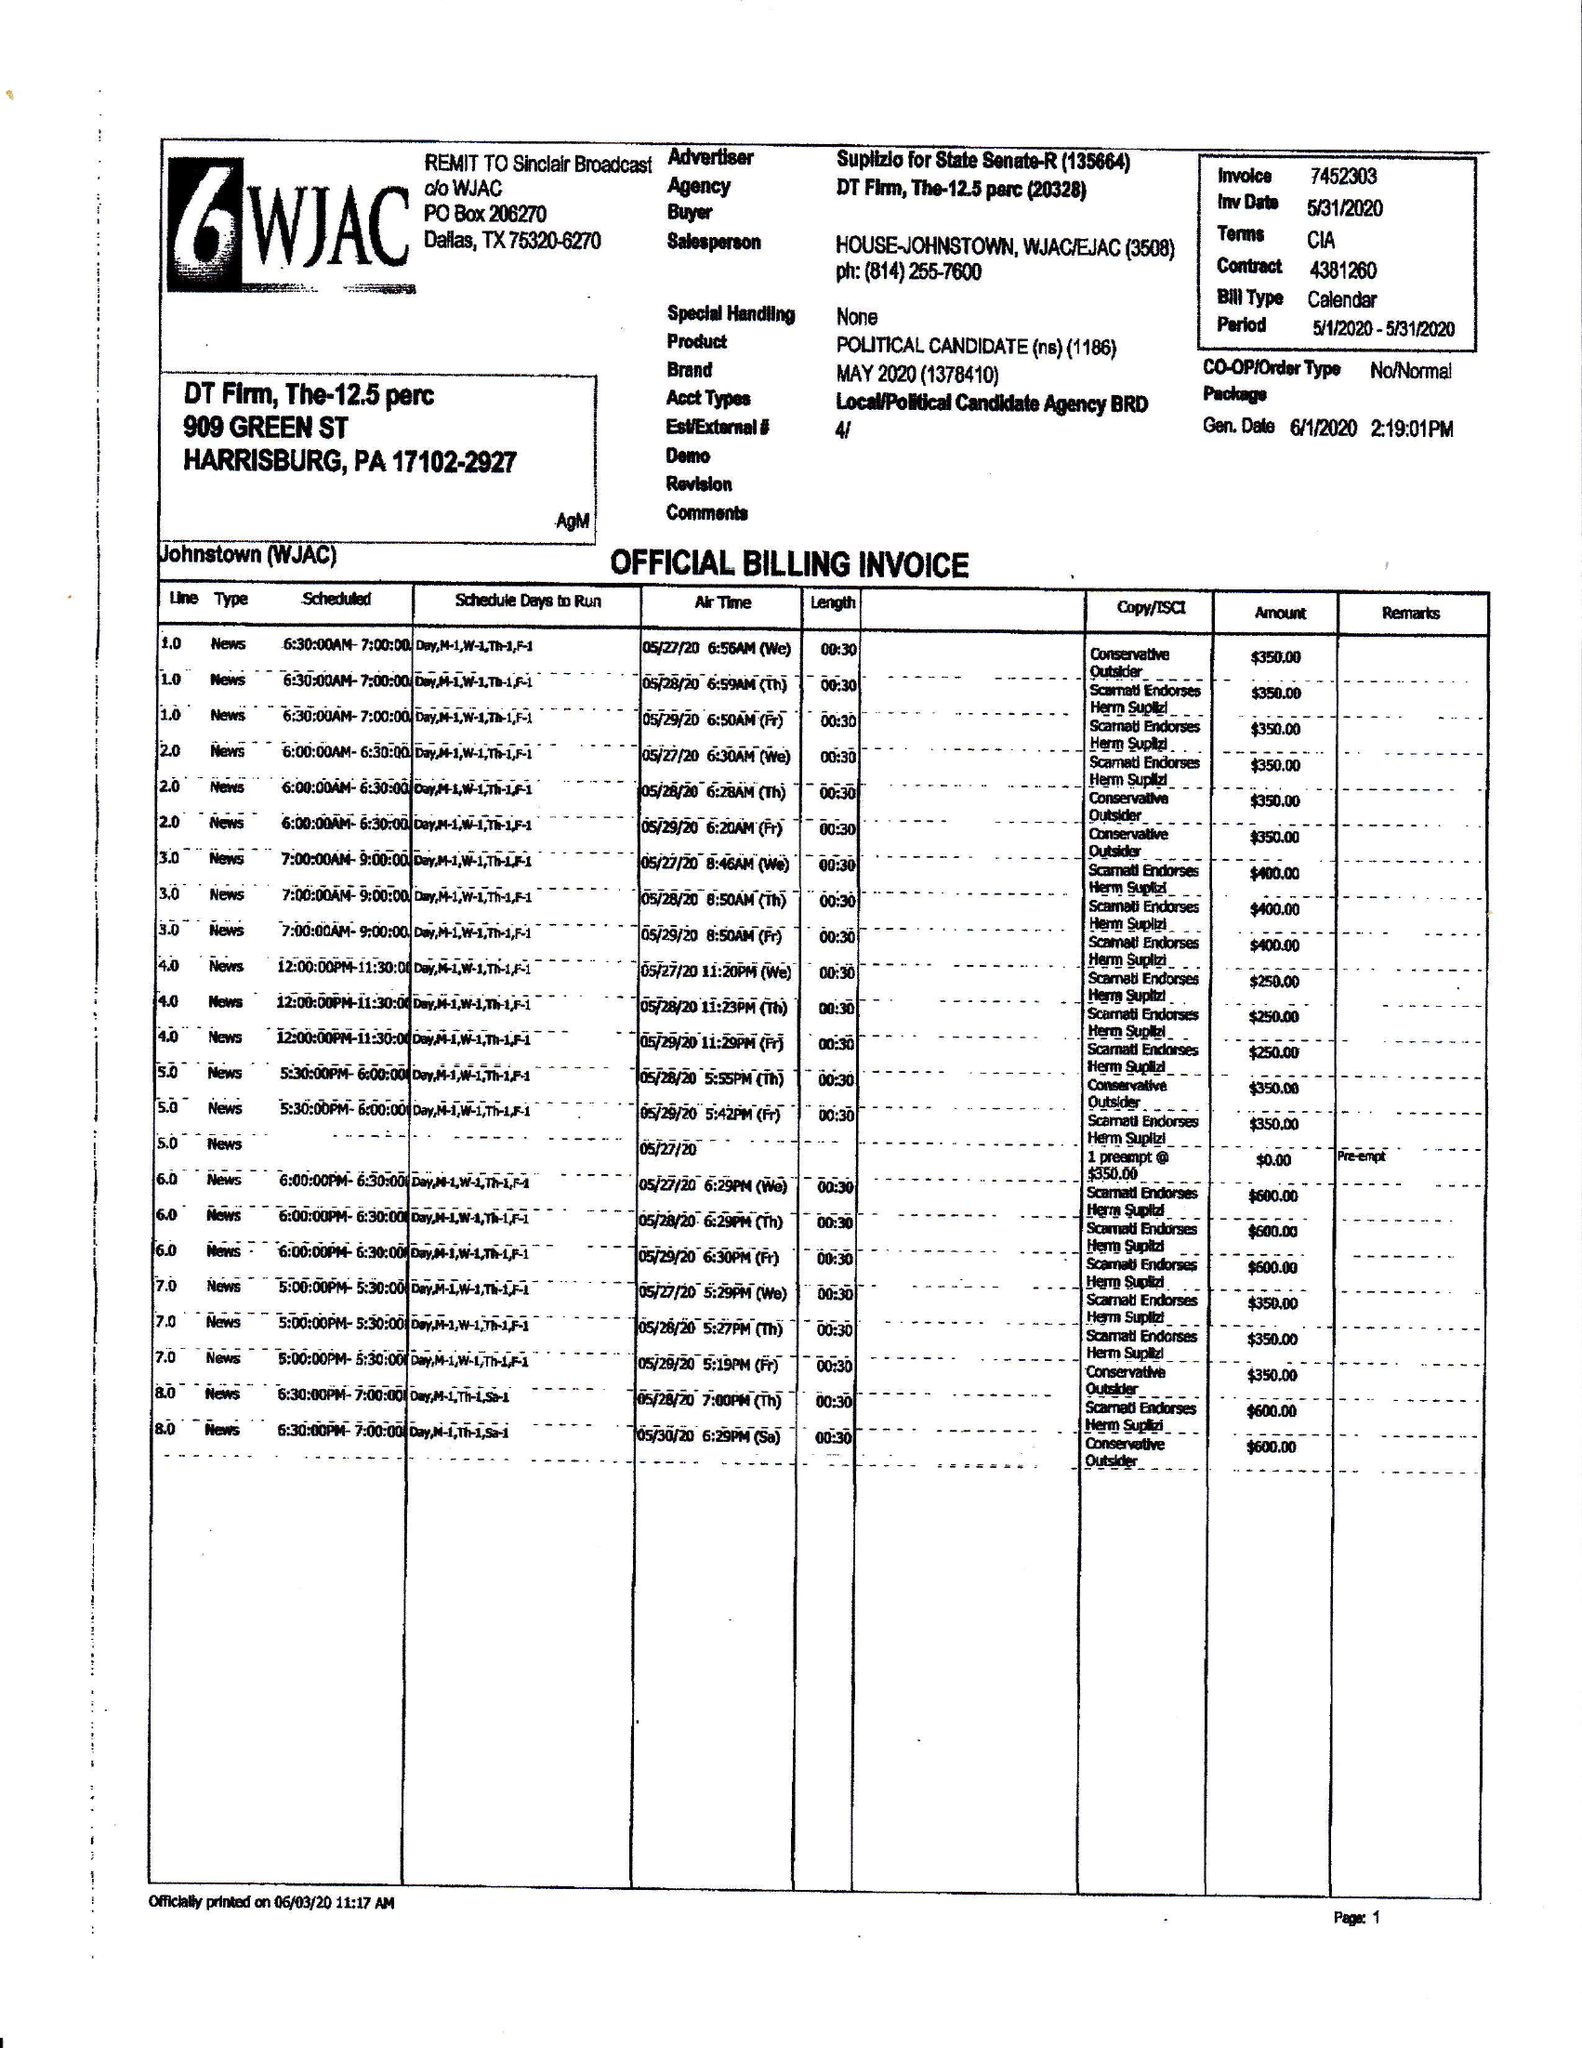What is the value for the gross_amount?
Answer the question using a single word or phrase. 8800.00 